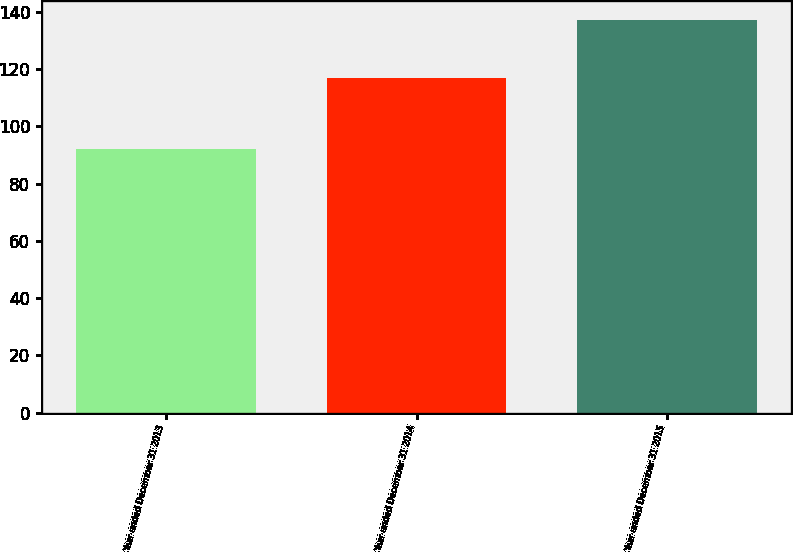Convert chart. <chart><loc_0><loc_0><loc_500><loc_500><bar_chart><fcel>Year ended December 31 2013<fcel>Year ended December 31 2014<fcel>Year ended December 31 2015<nl><fcel>92<fcel>117<fcel>137<nl></chart> 